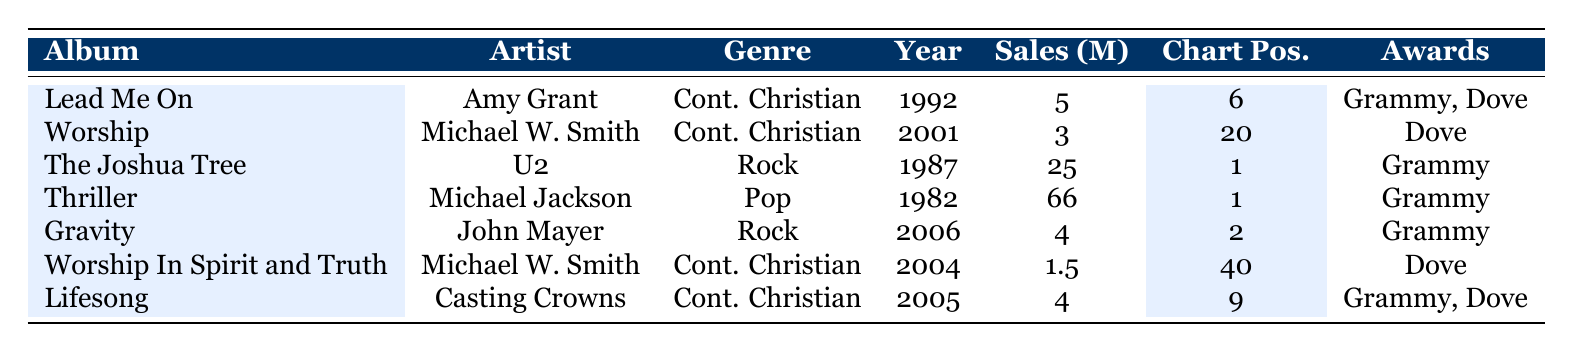What is the total sales in millions for Amy Grant's albums in the table? The table includes one album by Amy Grant, "Lead Me On," which has sales of 5 million. Therefore, the total sales for Amy Grant's albums in the table is simply 5 million.
Answer: 5 million What genre has the highest chart position in the table? Looking at the chart position column, "The Joshua Tree" by U2 (Rock) has a chart position of 1, which is the highest position in the table. Other genres do not have any album that ranks higher than that.
Answer: Rock How many albums by Michael W. Smith are represented in the table? The table lists two albums by Michael W. Smith: "Worship" and "Worship In Spirit and Truth." Thus, the total number of albums by him in the table is 2.
Answer: 2 What is the average sales in millions for Contemporary Christian music albums in the table? The table contains three Contemporary Christian albums: "Lead Me On" (5 million), "Worship" (3 million), and "Lifesong" (4 million). The total sales for these albums equal 5 + 3 + 4 = 12 million. There are 3 albums, so the average sales are 12/3 = 4 million.
Answer: 4 million Did any albums in the table receive more than one award? Yes, "Lead Me On" by Amy Grant and "Lifesong" by Casting Crowns both received two awards each (Grammy and Dove for both).
Answer: Yes What is the difference in sales between the highest-selling album and the lowest-selling Contemporary Christian album? The highest-selling album in the table is "Thriller" by Michael Jackson with sales of 66 million. The lowest-selling Contemporary Christian album is "Worship In Spirit and Truth" by Michael W. Smith with sales of 1.5 million. The difference in sales is 66 - 1.5 = 64.5 million.
Answer: 64.5 million Which album has the most awards, and how many do they have? "Lead Me On" by Amy Grant and "Lifesong" by Casting Crowns both have 2 awards listed (Grammy and Dove), which is the highest count in the table. So, both albums hold the title for the most awards with a total of 2 each.
Answer: Lead Me On and Lifesong; 2 awards each What year did the album "Gravity" by John Mayer come out? According to the table, "Gravity" by John Mayer was released in 2006. This is clearly listed in the year column for that album.
Answer: 2006 